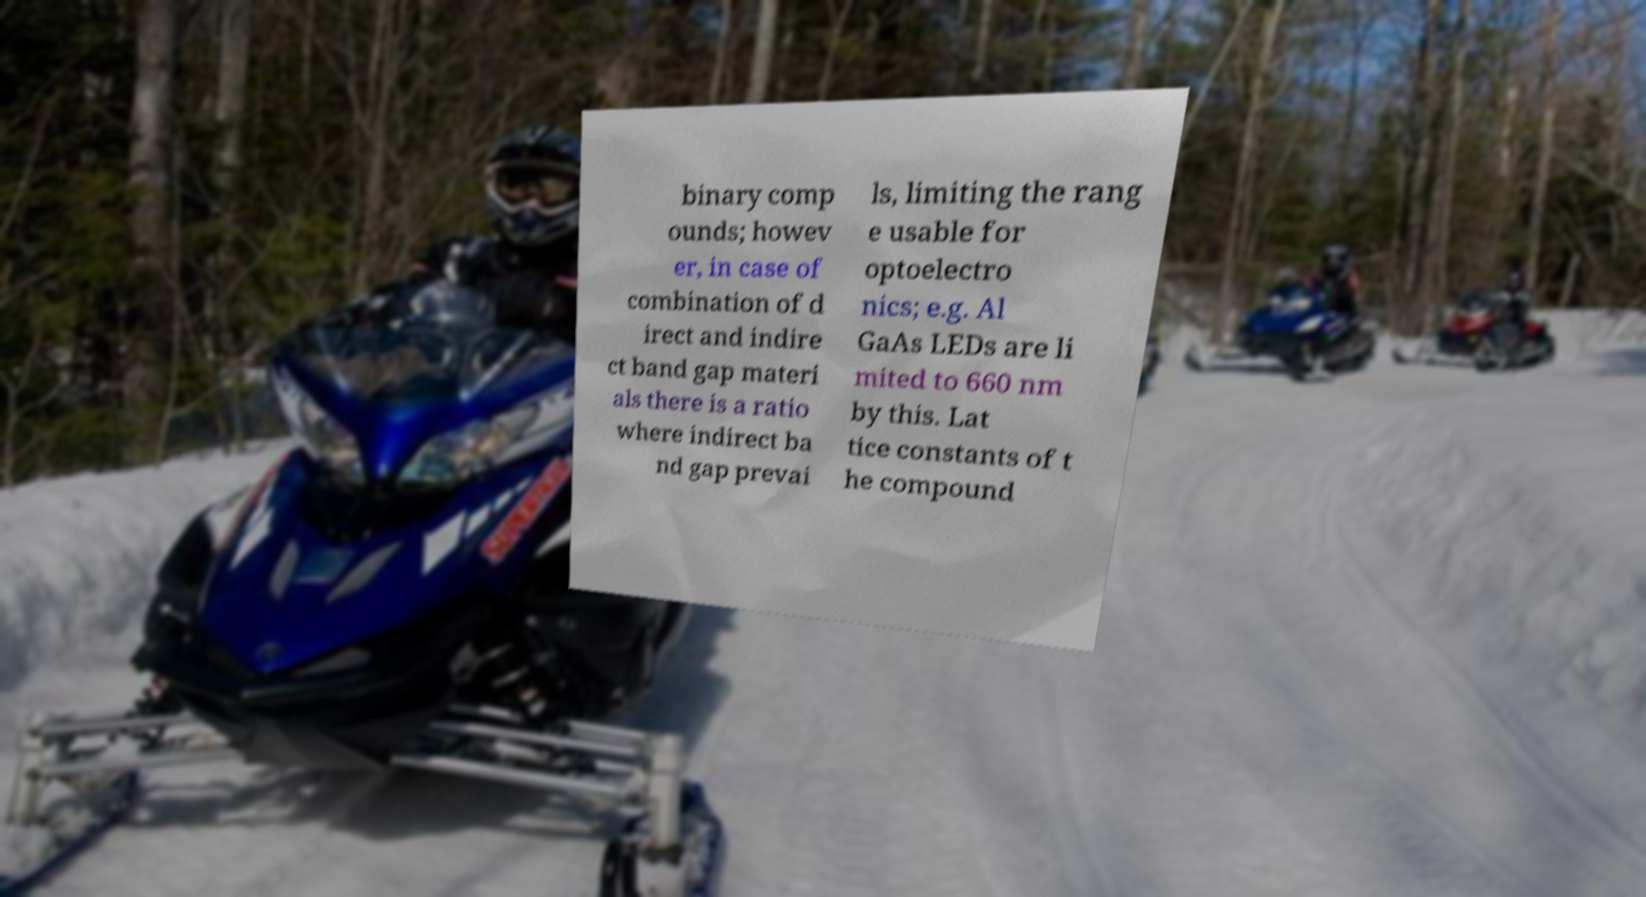Could you extract and type out the text from this image? binary comp ounds; howev er, in case of combination of d irect and indire ct band gap materi als there is a ratio where indirect ba nd gap prevai ls, limiting the rang e usable for optoelectro nics; e.g. Al GaAs LEDs are li mited to 660 nm by this. Lat tice constants of t he compound 